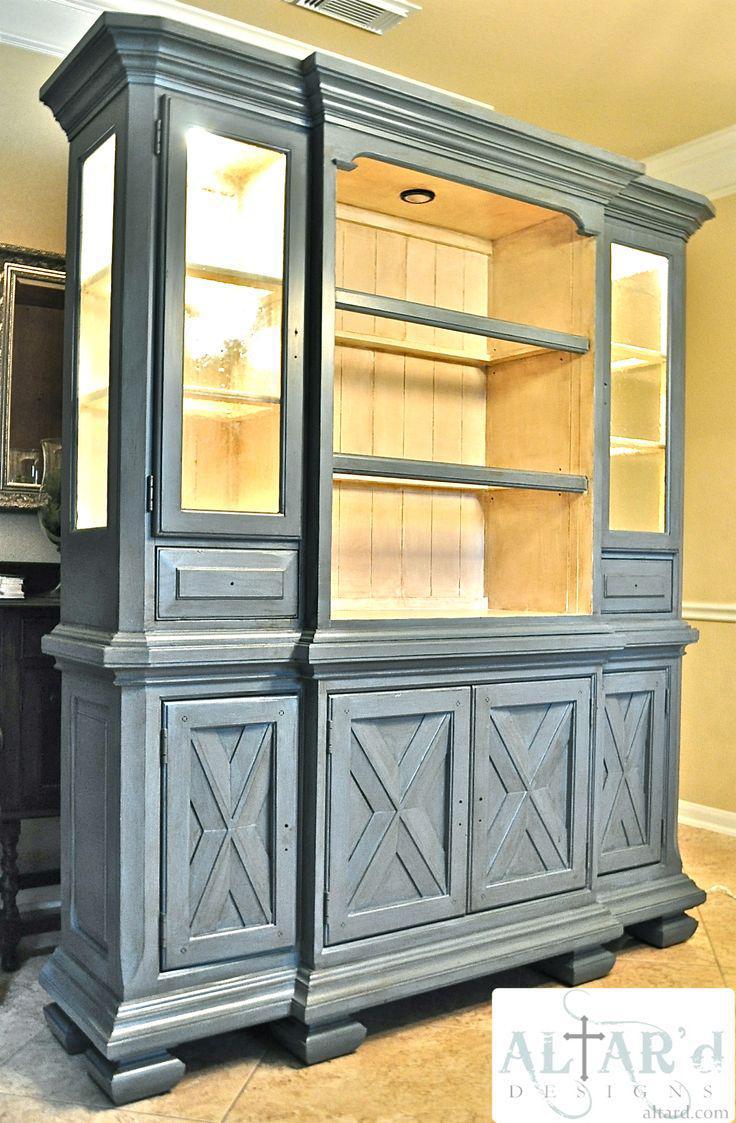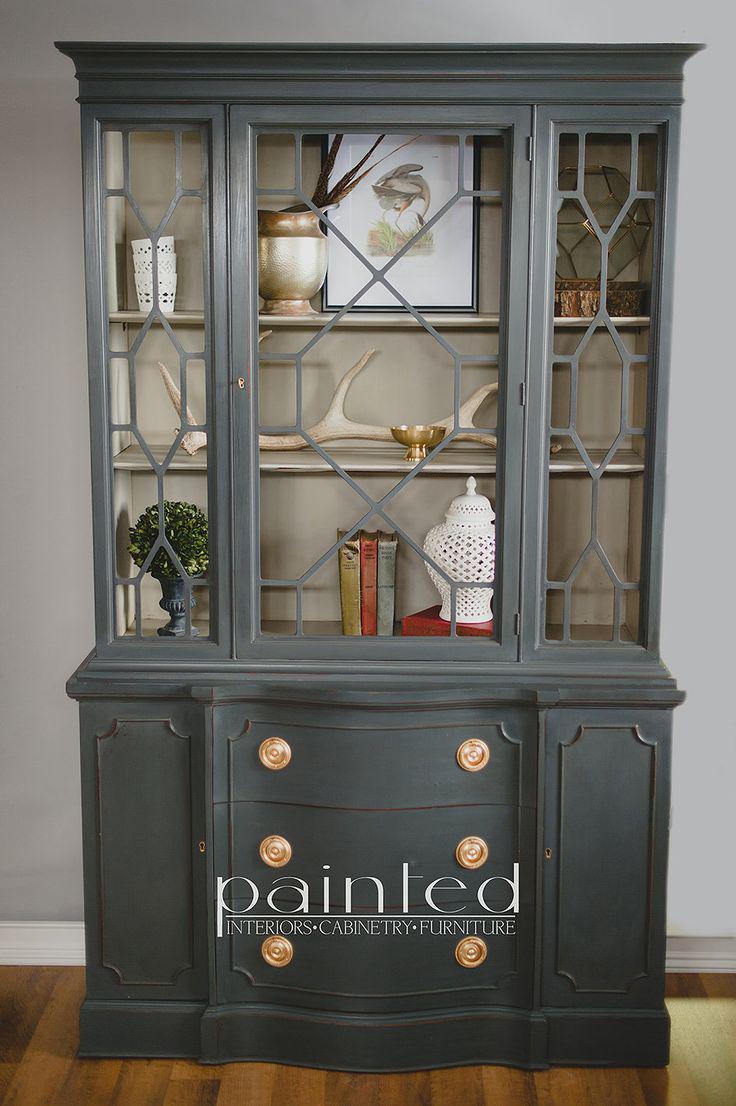The first image is the image on the left, the second image is the image on the right. Examine the images to the left and right. Is the description "There are gray diningroom hutches" accurate? Answer yes or no. Yes. The first image is the image on the left, the second image is the image on the right. Considering the images on both sides, is "One image features a cabinet with a curved top detail instead of a completely flat top." valid? Answer yes or no. No. 